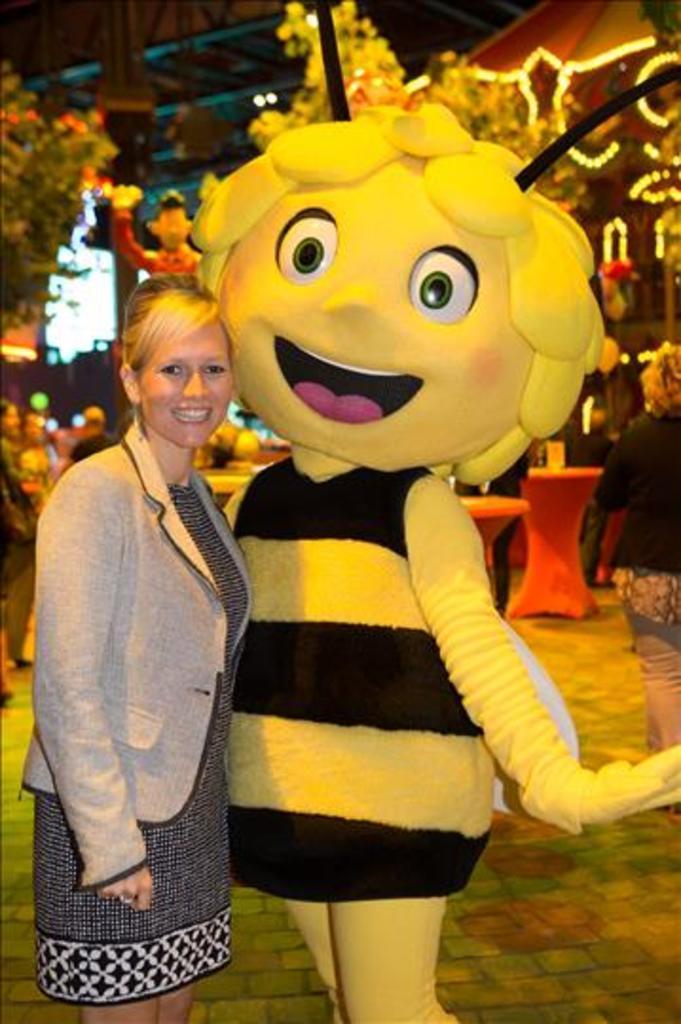How would you summarize this image in a sentence or two? In this image we can see a woman is standing at the mascot. In the background the image is not clear but we can see few persons, decorative lights, trees, poles and objects. 